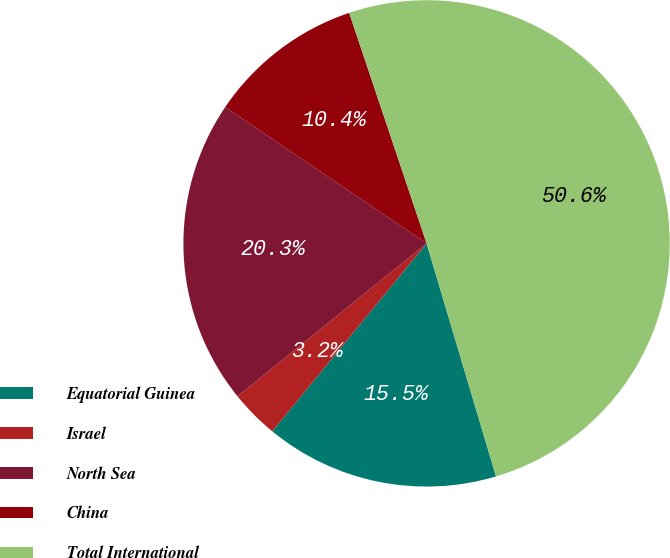Convert chart to OTSL. <chart><loc_0><loc_0><loc_500><loc_500><pie_chart><fcel>Equatorial Guinea<fcel>Israel<fcel>North Sea<fcel>China<fcel>Total International<nl><fcel>15.55%<fcel>3.24%<fcel>20.29%<fcel>10.37%<fcel>50.55%<nl></chart> 